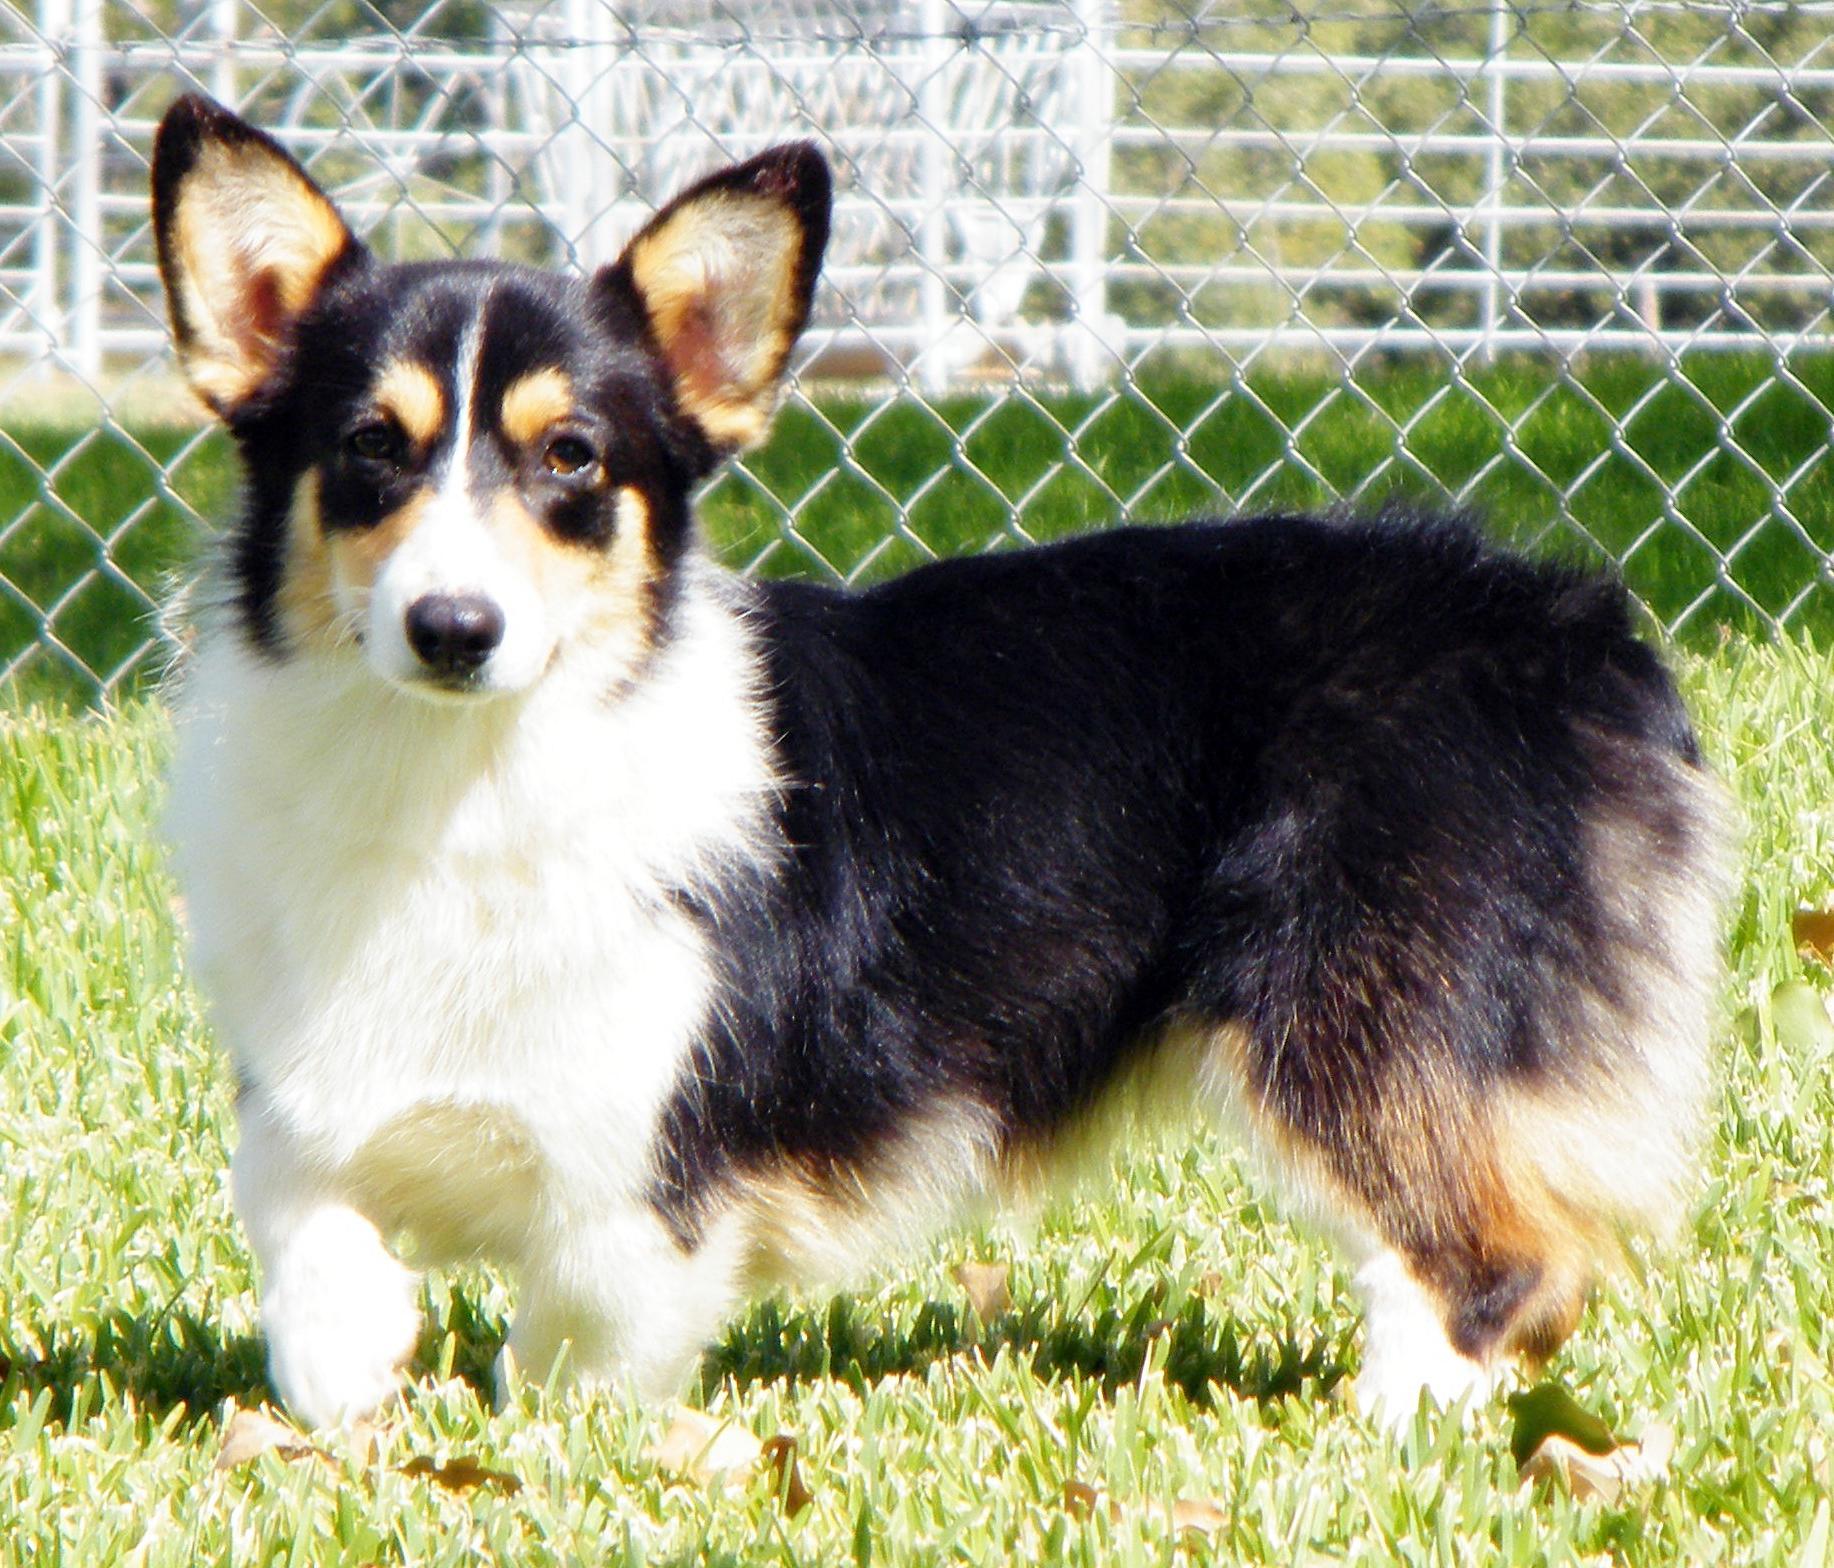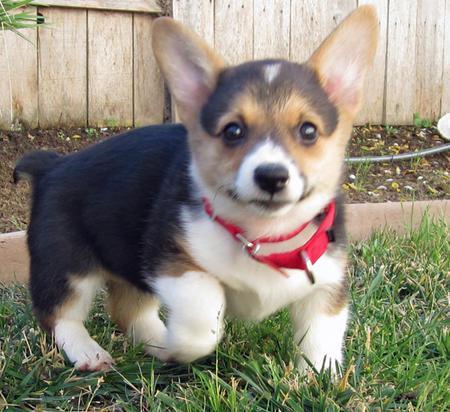The first image is the image on the left, the second image is the image on the right. Given the left and right images, does the statement "the left image has a sitting dog with its' tongue out" hold true? Answer yes or no. No. The first image is the image on the left, the second image is the image on the right. For the images shown, is this caption "One dog is looking to the right." true? Answer yes or no. No. 